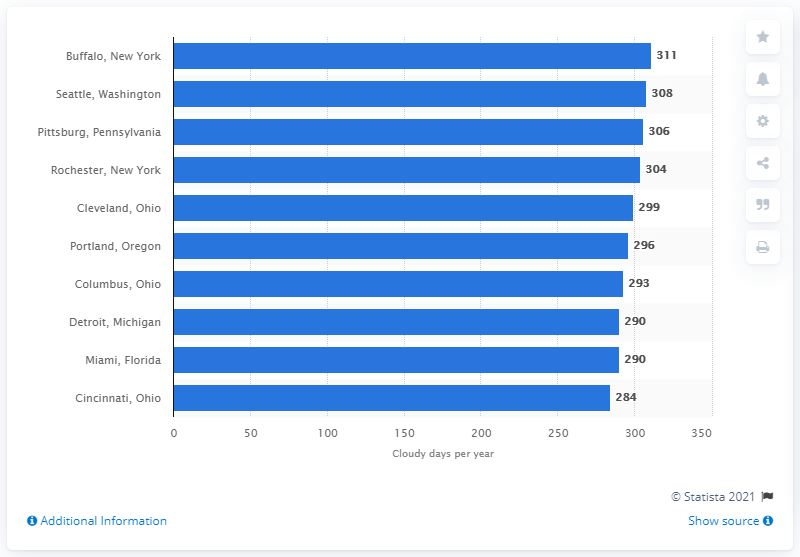Which city had the fewest number of cloudy days according to this bar graph? According to the bar graph in the image, Cincinnati, Ohio had the fewest number of cloudy days, with 284 days per year. 